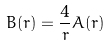<formula> <loc_0><loc_0><loc_500><loc_500>B ( r ) = \frac { 4 } { r } A ( r )</formula> 